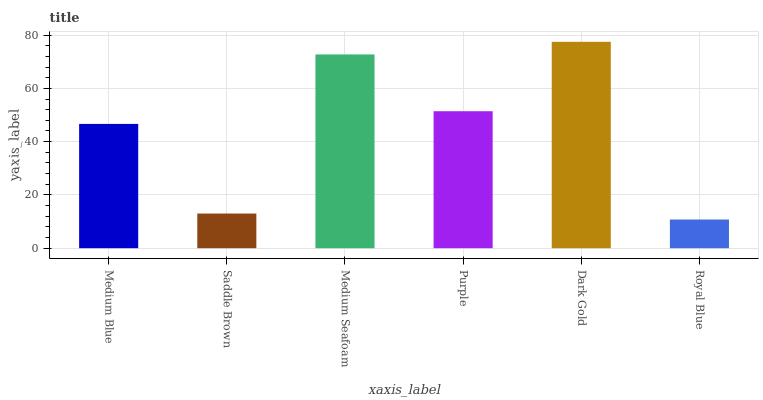Is Royal Blue the minimum?
Answer yes or no. Yes. Is Dark Gold the maximum?
Answer yes or no. Yes. Is Saddle Brown the minimum?
Answer yes or no. No. Is Saddle Brown the maximum?
Answer yes or no. No. Is Medium Blue greater than Saddle Brown?
Answer yes or no. Yes. Is Saddle Brown less than Medium Blue?
Answer yes or no. Yes. Is Saddle Brown greater than Medium Blue?
Answer yes or no. No. Is Medium Blue less than Saddle Brown?
Answer yes or no. No. Is Purple the high median?
Answer yes or no. Yes. Is Medium Blue the low median?
Answer yes or no. Yes. Is Dark Gold the high median?
Answer yes or no. No. Is Dark Gold the low median?
Answer yes or no. No. 